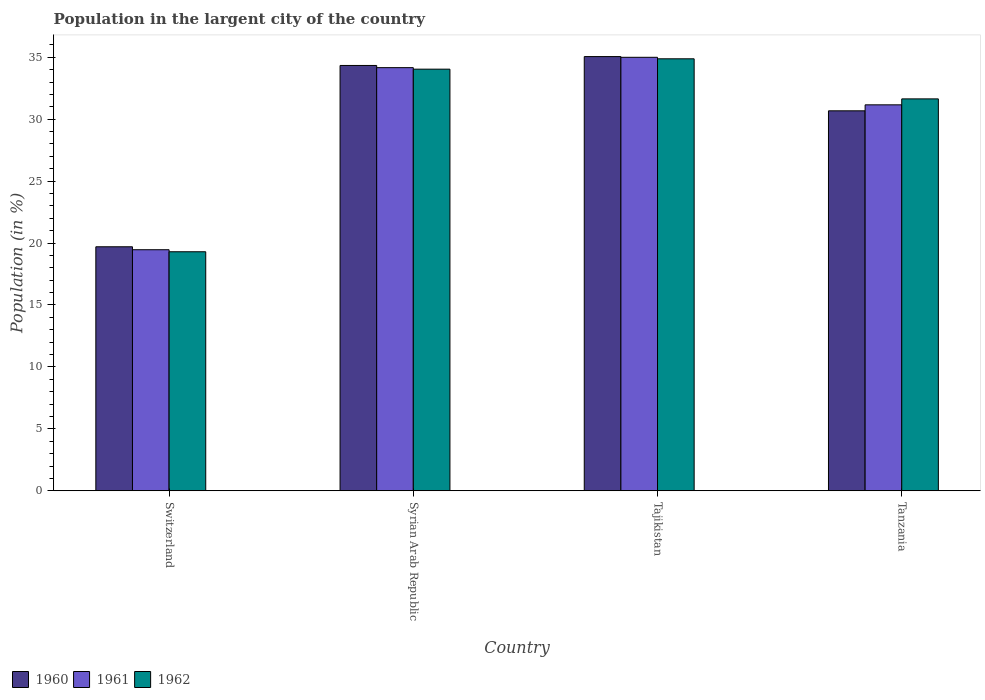How many different coloured bars are there?
Ensure brevity in your answer.  3. How many groups of bars are there?
Your response must be concise. 4. Are the number of bars per tick equal to the number of legend labels?
Keep it short and to the point. Yes. How many bars are there on the 3rd tick from the left?
Keep it short and to the point. 3. How many bars are there on the 1st tick from the right?
Make the answer very short. 3. What is the label of the 4th group of bars from the left?
Make the answer very short. Tanzania. What is the percentage of population in the largent city in 1960 in Tajikistan?
Your answer should be compact. 35.05. Across all countries, what is the maximum percentage of population in the largent city in 1962?
Your response must be concise. 34.88. Across all countries, what is the minimum percentage of population in the largent city in 1962?
Make the answer very short. 19.3. In which country was the percentage of population in the largent city in 1961 maximum?
Provide a short and direct response. Tajikistan. In which country was the percentage of population in the largent city in 1960 minimum?
Offer a terse response. Switzerland. What is the total percentage of population in the largent city in 1962 in the graph?
Provide a short and direct response. 119.85. What is the difference between the percentage of population in the largent city in 1961 in Switzerland and that in Tajikistan?
Your response must be concise. -15.54. What is the difference between the percentage of population in the largent city in 1962 in Switzerland and the percentage of population in the largent city in 1961 in Tajikistan?
Your answer should be very brief. -15.7. What is the average percentage of population in the largent city in 1961 per country?
Give a very brief answer. 29.94. What is the difference between the percentage of population in the largent city of/in 1961 and percentage of population in the largent city of/in 1962 in Switzerland?
Your answer should be compact. 0.16. What is the ratio of the percentage of population in the largent city in 1960 in Syrian Arab Republic to that in Tanzania?
Provide a short and direct response. 1.12. Is the percentage of population in the largent city in 1961 in Syrian Arab Republic less than that in Tajikistan?
Your answer should be very brief. Yes. Is the difference between the percentage of population in the largent city in 1961 in Switzerland and Tanzania greater than the difference between the percentage of population in the largent city in 1962 in Switzerland and Tanzania?
Provide a short and direct response. Yes. What is the difference between the highest and the second highest percentage of population in the largent city in 1962?
Your answer should be compact. 0.84. What is the difference between the highest and the lowest percentage of population in the largent city in 1960?
Offer a terse response. 15.36. In how many countries, is the percentage of population in the largent city in 1962 greater than the average percentage of population in the largent city in 1962 taken over all countries?
Your answer should be very brief. 3. Is the sum of the percentage of population in the largent city in 1960 in Switzerland and Tajikistan greater than the maximum percentage of population in the largent city in 1961 across all countries?
Ensure brevity in your answer.  Yes. What does the 2nd bar from the left in Switzerland represents?
Your response must be concise. 1961. How many bars are there?
Make the answer very short. 12. Are all the bars in the graph horizontal?
Ensure brevity in your answer.  No. How many countries are there in the graph?
Offer a terse response. 4. Are the values on the major ticks of Y-axis written in scientific E-notation?
Provide a short and direct response. No. Does the graph contain any zero values?
Offer a very short reply. No. Where does the legend appear in the graph?
Keep it short and to the point. Bottom left. What is the title of the graph?
Ensure brevity in your answer.  Population in the largent city of the country. Does "1999" appear as one of the legend labels in the graph?
Give a very brief answer. No. What is the Population (in %) in 1960 in Switzerland?
Ensure brevity in your answer.  19.7. What is the Population (in %) in 1961 in Switzerland?
Provide a short and direct response. 19.46. What is the Population (in %) of 1962 in Switzerland?
Provide a short and direct response. 19.3. What is the Population (in %) of 1960 in Syrian Arab Republic?
Offer a terse response. 34.34. What is the Population (in %) in 1961 in Syrian Arab Republic?
Your answer should be very brief. 34.16. What is the Population (in %) in 1962 in Syrian Arab Republic?
Offer a terse response. 34.04. What is the Population (in %) of 1960 in Tajikistan?
Give a very brief answer. 35.05. What is the Population (in %) of 1961 in Tajikistan?
Provide a short and direct response. 35. What is the Population (in %) of 1962 in Tajikistan?
Provide a short and direct response. 34.88. What is the Population (in %) of 1960 in Tanzania?
Offer a very short reply. 30.68. What is the Population (in %) in 1961 in Tanzania?
Your answer should be compact. 31.16. What is the Population (in %) in 1962 in Tanzania?
Make the answer very short. 31.64. Across all countries, what is the maximum Population (in %) of 1960?
Provide a succinct answer. 35.05. Across all countries, what is the maximum Population (in %) of 1961?
Give a very brief answer. 35. Across all countries, what is the maximum Population (in %) in 1962?
Offer a very short reply. 34.88. Across all countries, what is the minimum Population (in %) of 1960?
Offer a very short reply. 19.7. Across all countries, what is the minimum Population (in %) in 1961?
Offer a terse response. 19.46. Across all countries, what is the minimum Population (in %) in 1962?
Provide a succinct answer. 19.3. What is the total Population (in %) of 1960 in the graph?
Keep it short and to the point. 119.77. What is the total Population (in %) of 1961 in the graph?
Your answer should be very brief. 119.78. What is the total Population (in %) of 1962 in the graph?
Offer a terse response. 119.85. What is the difference between the Population (in %) in 1960 in Switzerland and that in Syrian Arab Republic?
Keep it short and to the point. -14.64. What is the difference between the Population (in %) of 1961 in Switzerland and that in Syrian Arab Republic?
Give a very brief answer. -14.7. What is the difference between the Population (in %) of 1962 in Switzerland and that in Syrian Arab Republic?
Provide a succinct answer. -14.74. What is the difference between the Population (in %) of 1960 in Switzerland and that in Tajikistan?
Your answer should be very brief. -15.36. What is the difference between the Population (in %) of 1961 in Switzerland and that in Tajikistan?
Offer a very short reply. -15.54. What is the difference between the Population (in %) in 1962 in Switzerland and that in Tajikistan?
Provide a short and direct response. -15.58. What is the difference between the Population (in %) of 1960 in Switzerland and that in Tanzania?
Your answer should be compact. -10.98. What is the difference between the Population (in %) in 1961 in Switzerland and that in Tanzania?
Make the answer very short. -11.7. What is the difference between the Population (in %) of 1962 in Switzerland and that in Tanzania?
Offer a very short reply. -12.34. What is the difference between the Population (in %) of 1960 in Syrian Arab Republic and that in Tajikistan?
Make the answer very short. -0.72. What is the difference between the Population (in %) in 1961 in Syrian Arab Republic and that in Tajikistan?
Offer a terse response. -0.84. What is the difference between the Population (in %) in 1962 in Syrian Arab Republic and that in Tajikistan?
Ensure brevity in your answer.  -0.84. What is the difference between the Population (in %) in 1960 in Syrian Arab Republic and that in Tanzania?
Provide a succinct answer. 3.66. What is the difference between the Population (in %) in 1961 in Syrian Arab Republic and that in Tanzania?
Make the answer very short. 3. What is the difference between the Population (in %) of 1962 in Syrian Arab Republic and that in Tanzania?
Your answer should be very brief. 2.4. What is the difference between the Population (in %) of 1960 in Tajikistan and that in Tanzania?
Ensure brevity in your answer.  4.38. What is the difference between the Population (in %) in 1961 in Tajikistan and that in Tanzania?
Your answer should be very brief. 3.84. What is the difference between the Population (in %) in 1962 in Tajikistan and that in Tanzania?
Your answer should be very brief. 3.24. What is the difference between the Population (in %) of 1960 in Switzerland and the Population (in %) of 1961 in Syrian Arab Republic?
Ensure brevity in your answer.  -14.46. What is the difference between the Population (in %) of 1960 in Switzerland and the Population (in %) of 1962 in Syrian Arab Republic?
Offer a terse response. -14.34. What is the difference between the Population (in %) of 1961 in Switzerland and the Population (in %) of 1962 in Syrian Arab Republic?
Provide a short and direct response. -14.58. What is the difference between the Population (in %) of 1960 in Switzerland and the Population (in %) of 1961 in Tajikistan?
Offer a terse response. -15.3. What is the difference between the Population (in %) of 1960 in Switzerland and the Population (in %) of 1962 in Tajikistan?
Your response must be concise. -15.18. What is the difference between the Population (in %) in 1961 in Switzerland and the Population (in %) in 1962 in Tajikistan?
Your answer should be compact. -15.41. What is the difference between the Population (in %) in 1960 in Switzerland and the Population (in %) in 1961 in Tanzania?
Offer a very short reply. -11.46. What is the difference between the Population (in %) of 1960 in Switzerland and the Population (in %) of 1962 in Tanzania?
Make the answer very short. -11.94. What is the difference between the Population (in %) in 1961 in Switzerland and the Population (in %) in 1962 in Tanzania?
Make the answer very short. -12.18. What is the difference between the Population (in %) in 1960 in Syrian Arab Republic and the Population (in %) in 1961 in Tajikistan?
Keep it short and to the point. -0.66. What is the difference between the Population (in %) of 1960 in Syrian Arab Republic and the Population (in %) of 1962 in Tajikistan?
Make the answer very short. -0.54. What is the difference between the Population (in %) in 1961 in Syrian Arab Republic and the Population (in %) in 1962 in Tajikistan?
Your answer should be compact. -0.71. What is the difference between the Population (in %) in 1960 in Syrian Arab Republic and the Population (in %) in 1961 in Tanzania?
Provide a succinct answer. 3.18. What is the difference between the Population (in %) in 1960 in Syrian Arab Republic and the Population (in %) in 1962 in Tanzania?
Make the answer very short. 2.7. What is the difference between the Population (in %) in 1961 in Syrian Arab Republic and the Population (in %) in 1962 in Tanzania?
Provide a succinct answer. 2.52. What is the difference between the Population (in %) in 1960 in Tajikistan and the Population (in %) in 1961 in Tanzania?
Your response must be concise. 3.9. What is the difference between the Population (in %) in 1960 in Tajikistan and the Population (in %) in 1962 in Tanzania?
Provide a succinct answer. 3.42. What is the difference between the Population (in %) in 1961 in Tajikistan and the Population (in %) in 1962 in Tanzania?
Make the answer very short. 3.36. What is the average Population (in %) in 1960 per country?
Offer a very short reply. 29.94. What is the average Population (in %) of 1961 per country?
Give a very brief answer. 29.94. What is the average Population (in %) in 1962 per country?
Offer a terse response. 29.96. What is the difference between the Population (in %) in 1960 and Population (in %) in 1961 in Switzerland?
Ensure brevity in your answer.  0.24. What is the difference between the Population (in %) in 1960 and Population (in %) in 1962 in Switzerland?
Offer a very short reply. 0.4. What is the difference between the Population (in %) in 1961 and Population (in %) in 1962 in Switzerland?
Offer a very short reply. 0.16. What is the difference between the Population (in %) of 1960 and Population (in %) of 1961 in Syrian Arab Republic?
Make the answer very short. 0.18. What is the difference between the Population (in %) in 1960 and Population (in %) in 1962 in Syrian Arab Republic?
Offer a very short reply. 0.3. What is the difference between the Population (in %) of 1961 and Population (in %) of 1962 in Syrian Arab Republic?
Offer a terse response. 0.12. What is the difference between the Population (in %) in 1960 and Population (in %) in 1961 in Tajikistan?
Provide a succinct answer. 0.06. What is the difference between the Population (in %) of 1960 and Population (in %) of 1962 in Tajikistan?
Provide a short and direct response. 0.18. What is the difference between the Population (in %) in 1961 and Population (in %) in 1962 in Tajikistan?
Keep it short and to the point. 0.12. What is the difference between the Population (in %) of 1960 and Population (in %) of 1961 in Tanzania?
Keep it short and to the point. -0.48. What is the difference between the Population (in %) of 1960 and Population (in %) of 1962 in Tanzania?
Your answer should be compact. -0.96. What is the difference between the Population (in %) in 1961 and Population (in %) in 1962 in Tanzania?
Keep it short and to the point. -0.48. What is the ratio of the Population (in %) of 1960 in Switzerland to that in Syrian Arab Republic?
Make the answer very short. 0.57. What is the ratio of the Population (in %) of 1961 in Switzerland to that in Syrian Arab Republic?
Make the answer very short. 0.57. What is the ratio of the Population (in %) of 1962 in Switzerland to that in Syrian Arab Republic?
Keep it short and to the point. 0.57. What is the ratio of the Population (in %) in 1960 in Switzerland to that in Tajikistan?
Provide a succinct answer. 0.56. What is the ratio of the Population (in %) in 1961 in Switzerland to that in Tajikistan?
Provide a short and direct response. 0.56. What is the ratio of the Population (in %) in 1962 in Switzerland to that in Tajikistan?
Provide a short and direct response. 0.55. What is the ratio of the Population (in %) in 1960 in Switzerland to that in Tanzania?
Provide a succinct answer. 0.64. What is the ratio of the Population (in %) in 1961 in Switzerland to that in Tanzania?
Ensure brevity in your answer.  0.62. What is the ratio of the Population (in %) in 1962 in Switzerland to that in Tanzania?
Offer a very short reply. 0.61. What is the ratio of the Population (in %) in 1960 in Syrian Arab Republic to that in Tajikistan?
Make the answer very short. 0.98. What is the ratio of the Population (in %) in 1961 in Syrian Arab Republic to that in Tajikistan?
Your answer should be compact. 0.98. What is the ratio of the Population (in %) of 1960 in Syrian Arab Republic to that in Tanzania?
Provide a succinct answer. 1.12. What is the ratio of the Population (in %) of 1961 in Syrian Arab Republic to that in Tanzania?
Provide a short and direct response. 1.1. What is the ratio of the Population (in %) in 1962 in Syrian Arab Republic to that in Tanzania?
Your response must be concise. 1.08. What is the ratio of the Population (in %) of 1960 in Tajikistan to that in Tanzania?
Give a very brief answer. 1.14. What is the ratio of the Population (in %) of 1961 in Tajikistan to that in Tanzania?
Provide a succinct answer. 1.12. What is the ratio of the Population (in %) of 1962 in Tajikistan to that in Tanzania?
Ensure brevity in your answer.  1.1. What is the difference between the highest and the second highest Population (in %) in 1960?
Your answer should be very brief. 0.72. What is the difference between the highest and the second highest Population (in %) of 1961?
Offer a very short reply. 0.84. What is the difference between the highest and the second highest Population (in %) in 1962?
Make the answer very short. 0.84. What is the difference between the highest and the lowest Population (in %) in 1960?
Keep it short and to the point. 15.36. What is the difference between the highest and the lowest Population (in %) of 1961?
Offer a very short reply. 15.54. What is the difference between the highest and the lowest Population (in %) of 1962?
Make the answer very short. 15.58. 